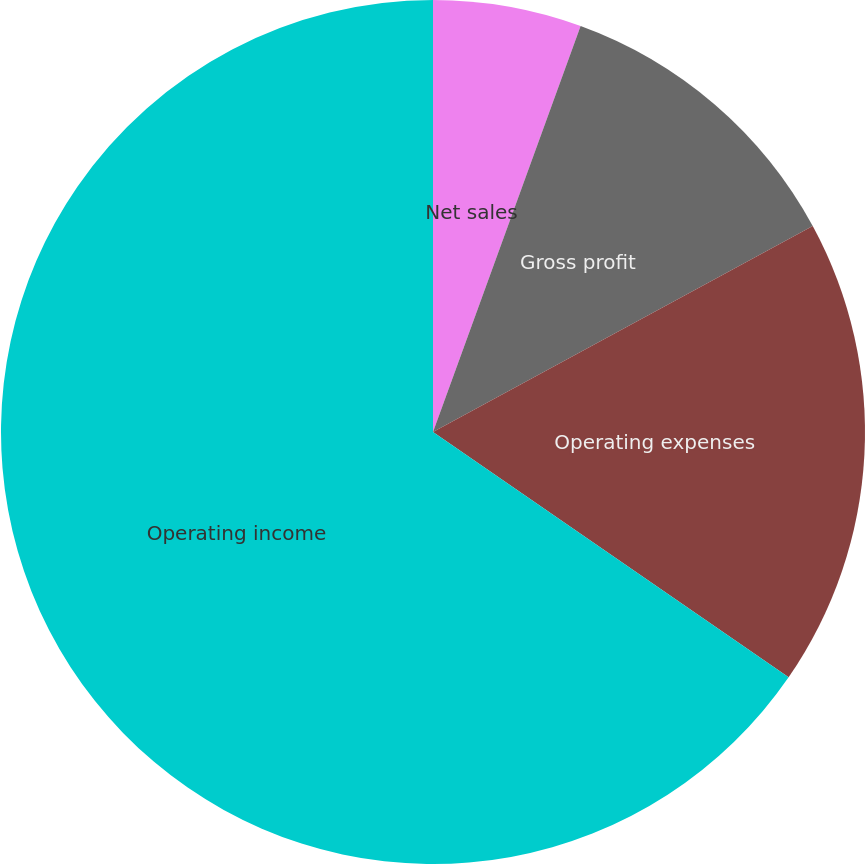<chart> <loc_0><loc_0><loc_500><loc_500><pie_chart><fcel>Net sales<fcel>Gross profit<fcel>Operating expenses<fcel>Operating income<nl><fcel>5.55%<fcel>11.54%<fcel>17.52%<fcel>65.39%<nl></chart> 